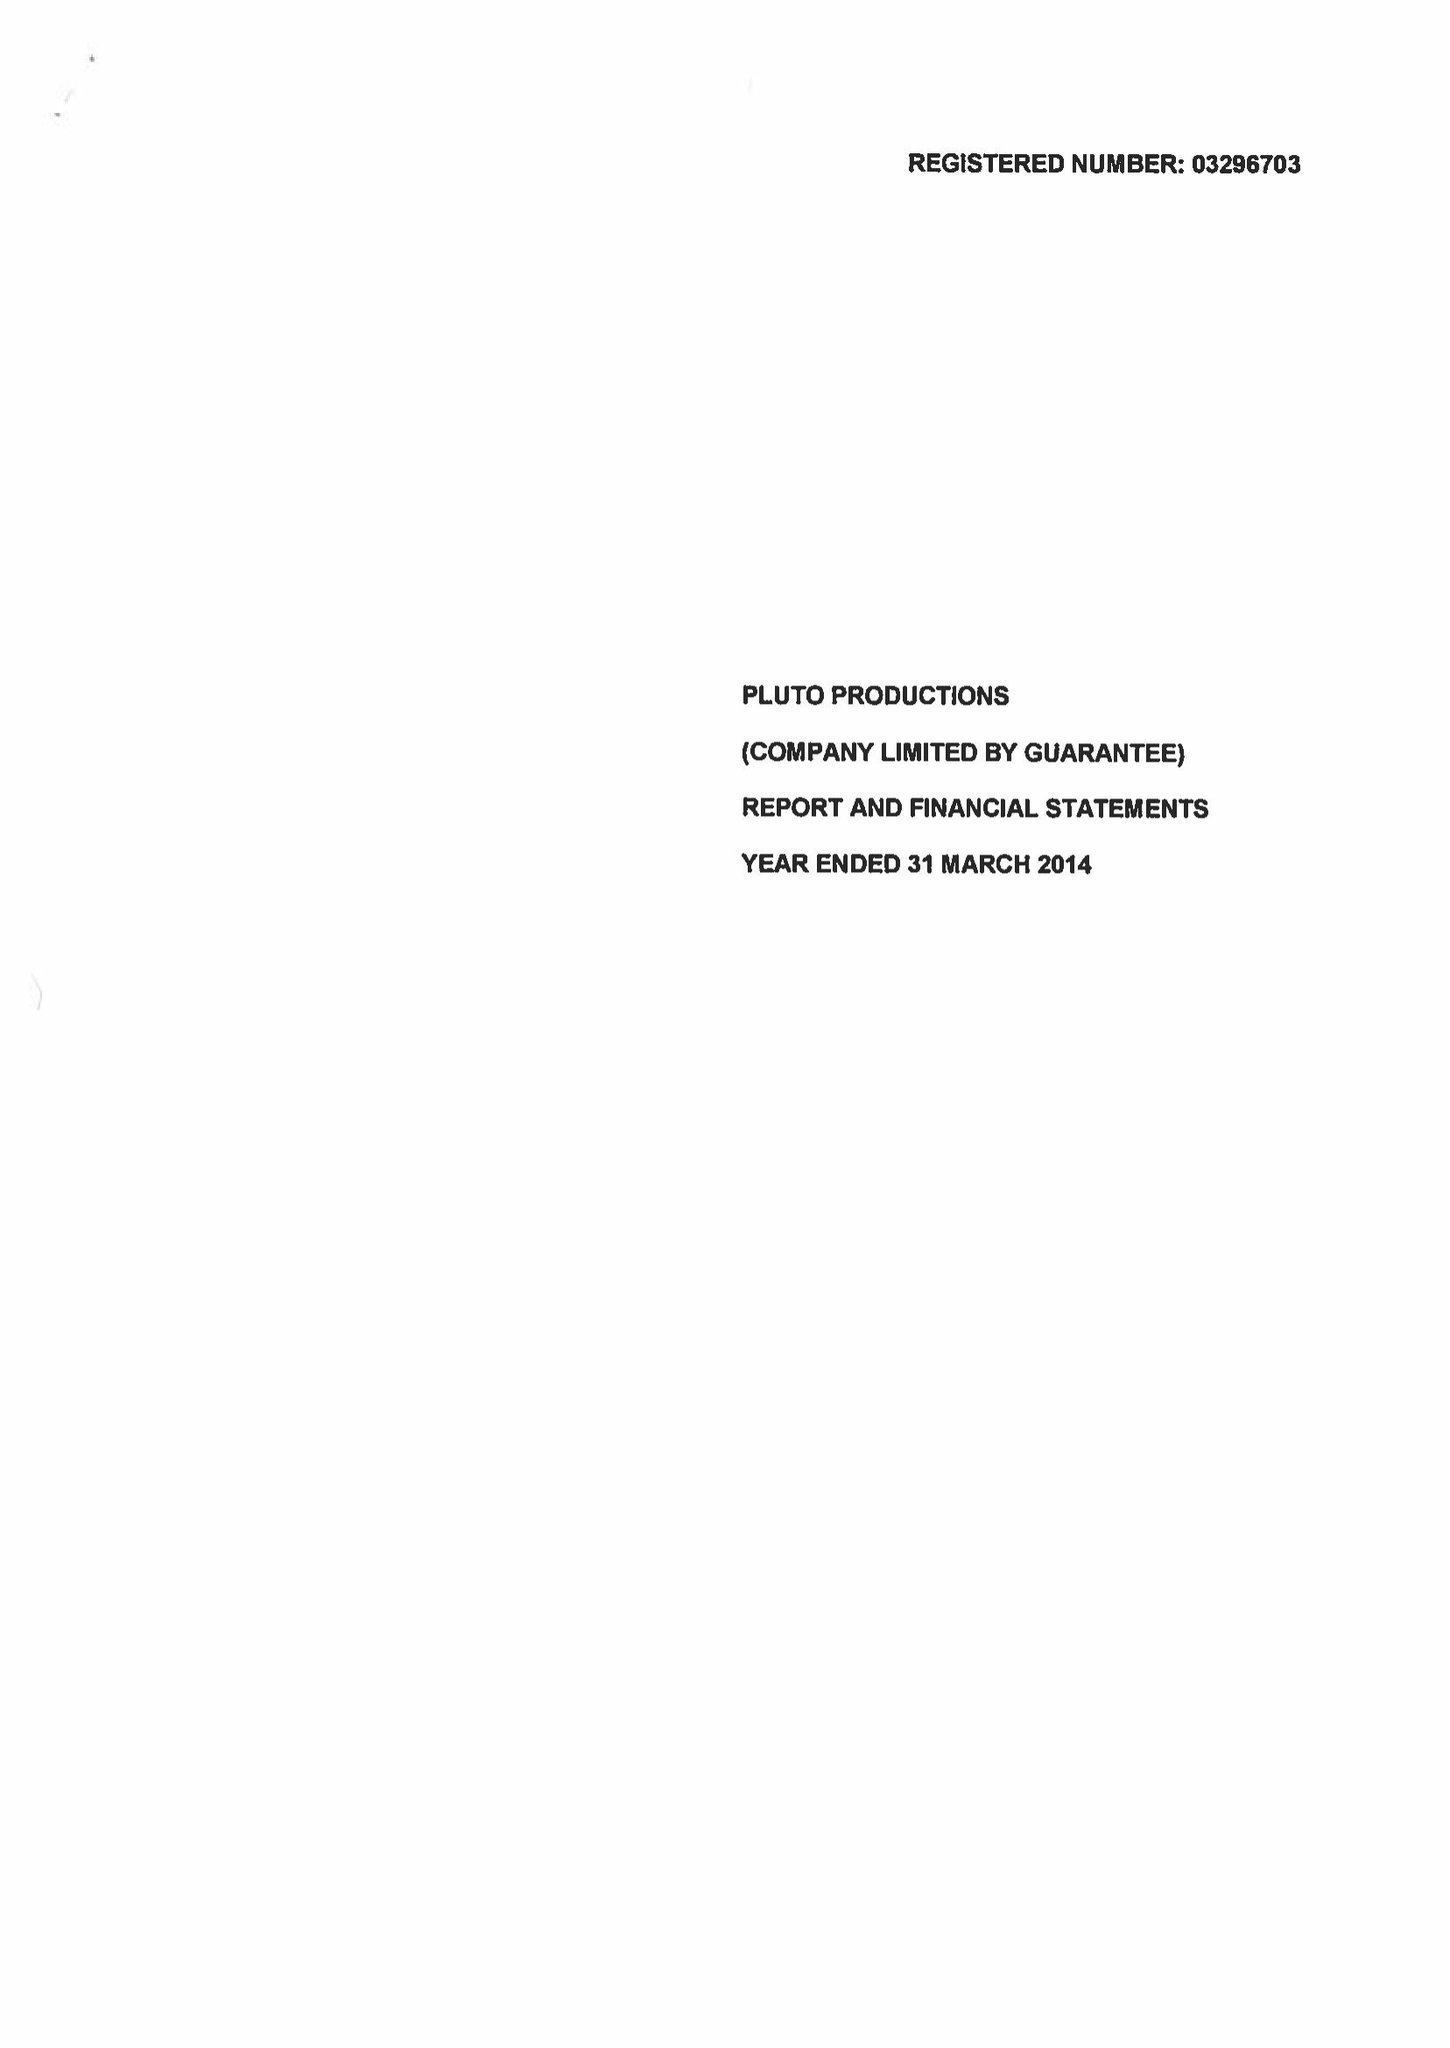What is the value for the charity_number?
Answer the question using a single word or phrase. 1062498 